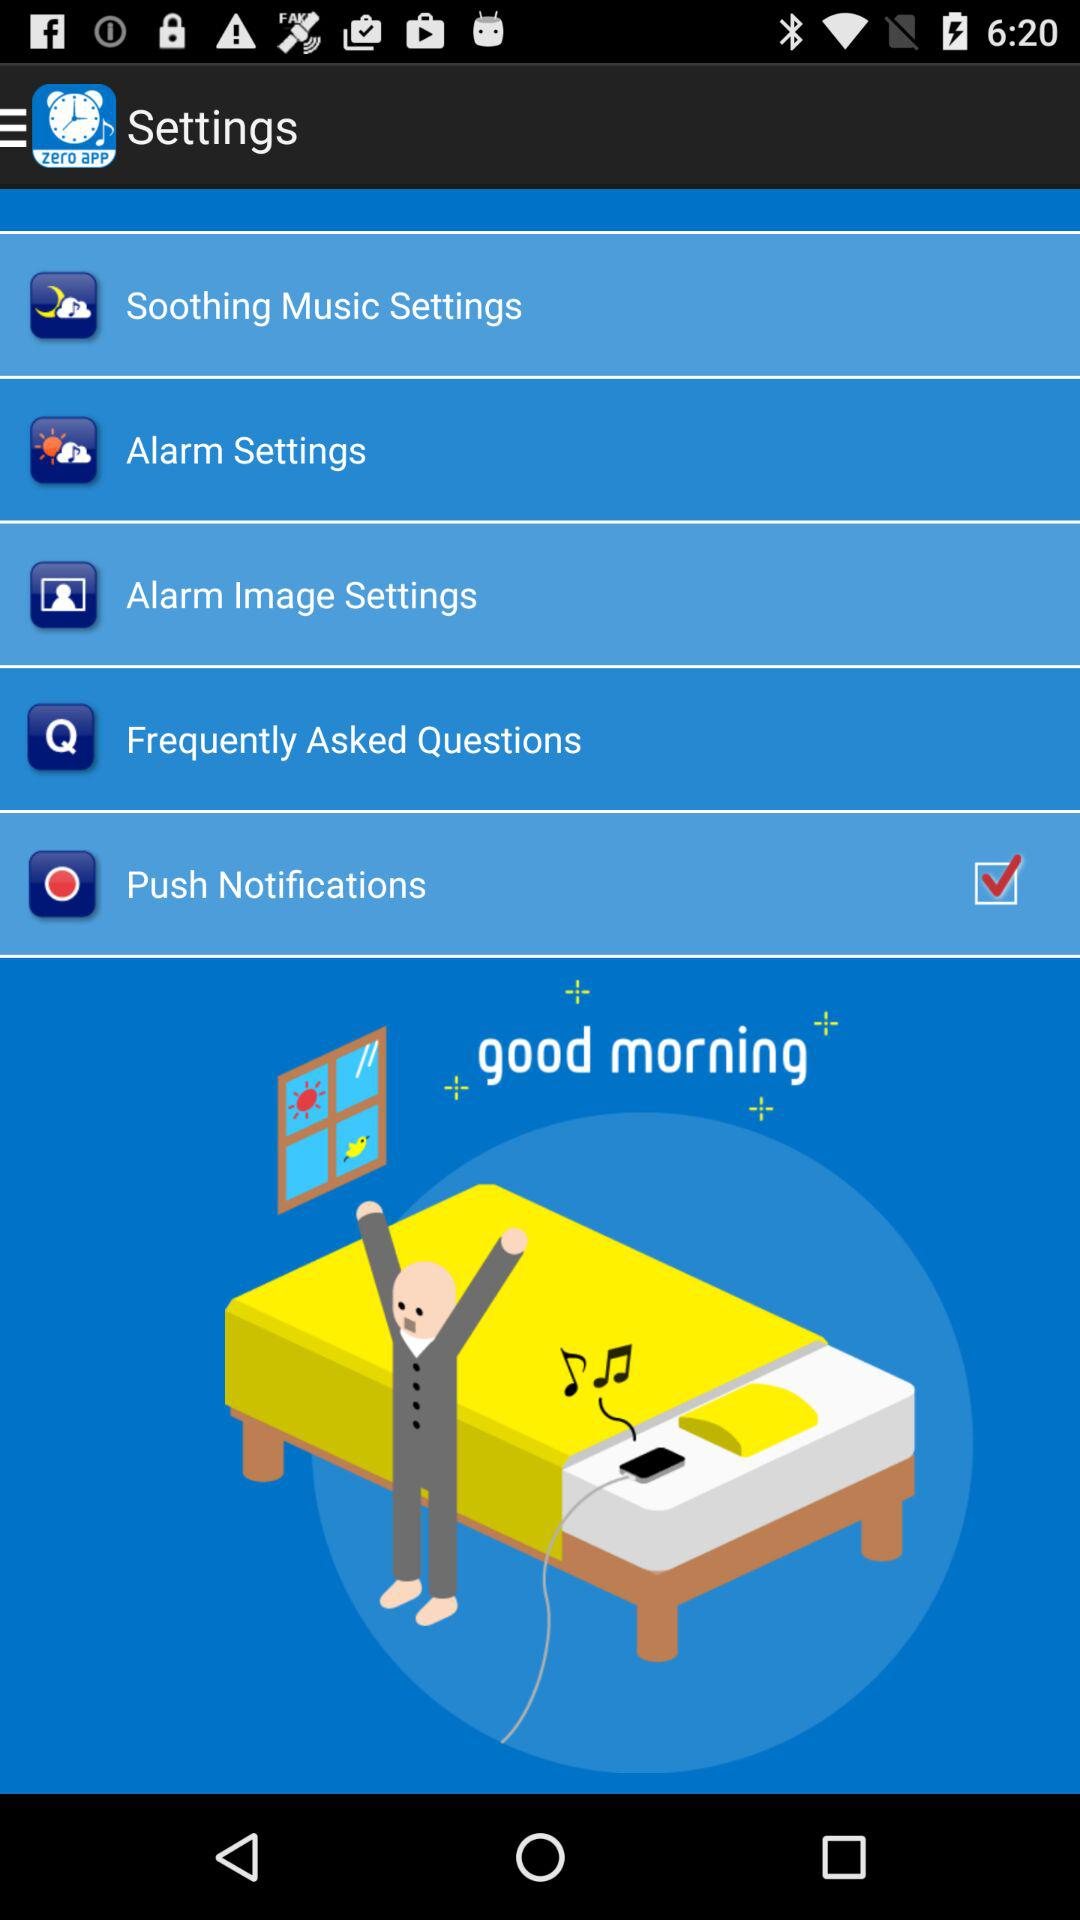What is the version of this application?
When the provided information is insufficient, respond with <no answer>. <no answer> 